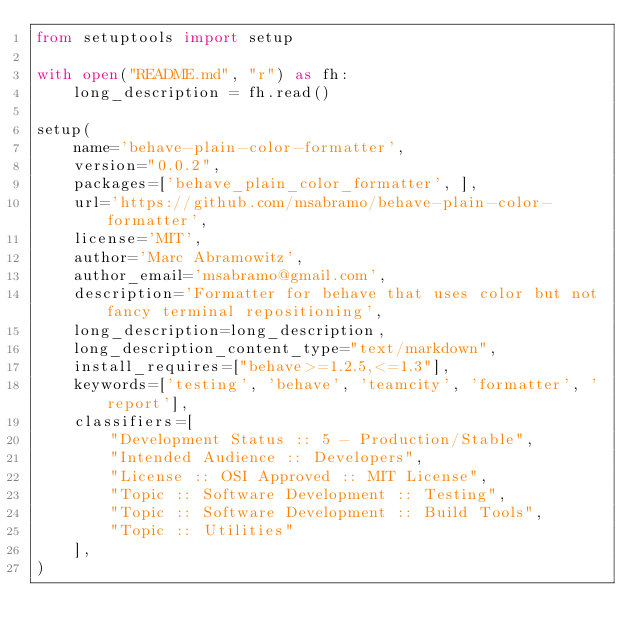<code> <loc_0><loc_0><loc_500><loc_500><_Python_>from setuptools import setup

with open("README.md", "r") as fh:
    long_description = fh.read()

setup(
    name='behave-plain-color-formatter',
    version="0.0.2",
    packages=['behave_plain_color_formatter', ],
    url='https://github.com/msabramo/behave-plain-color-formatter',
    license='MIT',
    author='Marc Abramowitz',
    author_email='msabramo@gmail.com',
    description='Formatter for behave that uses color but not fancy terminal repositioning',
    long_description=long_description,
    long_description_content_type="text/markdown",
    install_requires=["behave>=1.2.5,<=1.3"],
    keywords=['testing', 'behave', 'teamcity', 'formatter', 'report'],
    classifiers=[
        "Development Status :: 5 - Production/Stable",
        "Intended Audience :: Developers",
        "License :: OSI Approved :: MIT License",
        "Topic :: Software Development :: Testing",
        "Topic :: Software Development :: Build Tools",
        "Topic :: Utilities"
    ],
)
</code> 